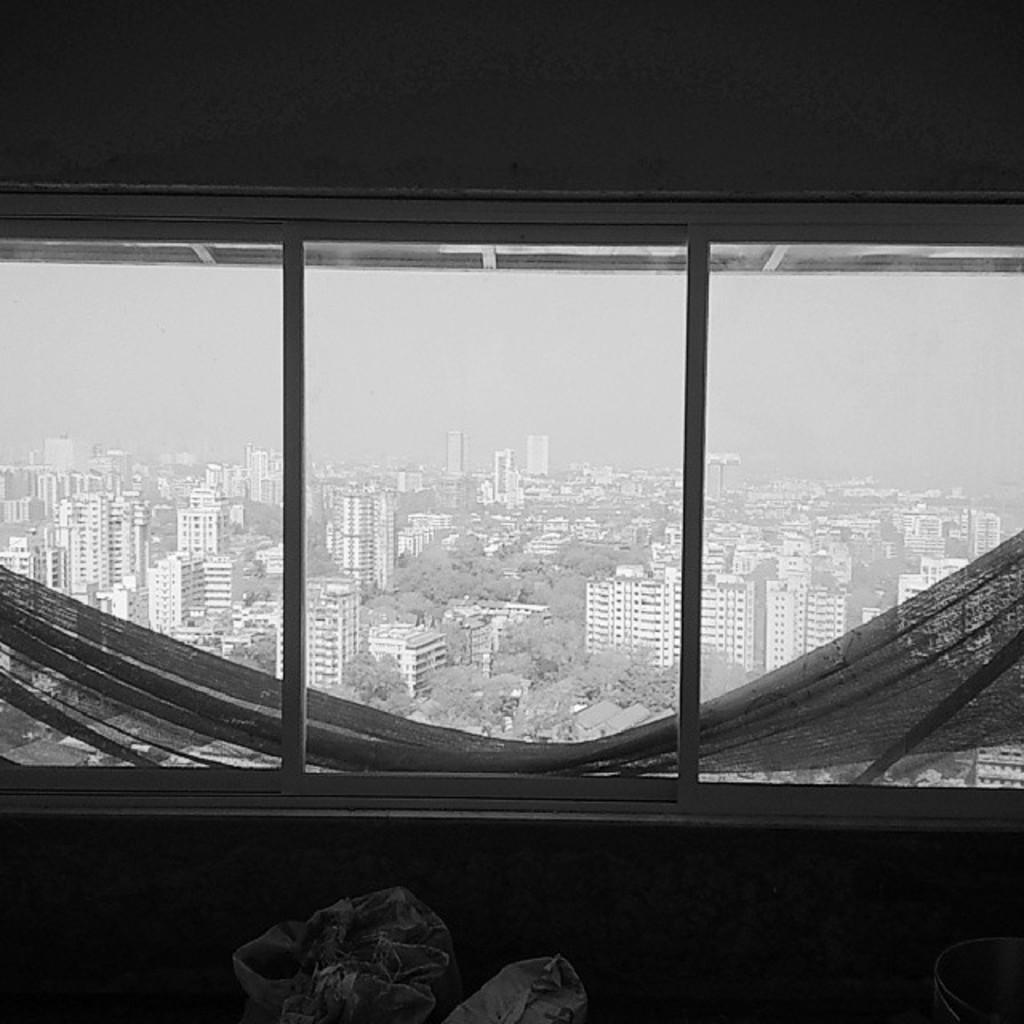Describe this image in one or two sentences. In this image we can see there is a window and the wall and through the window we can see there are buildings, trees, bags, cloth and the sky. 